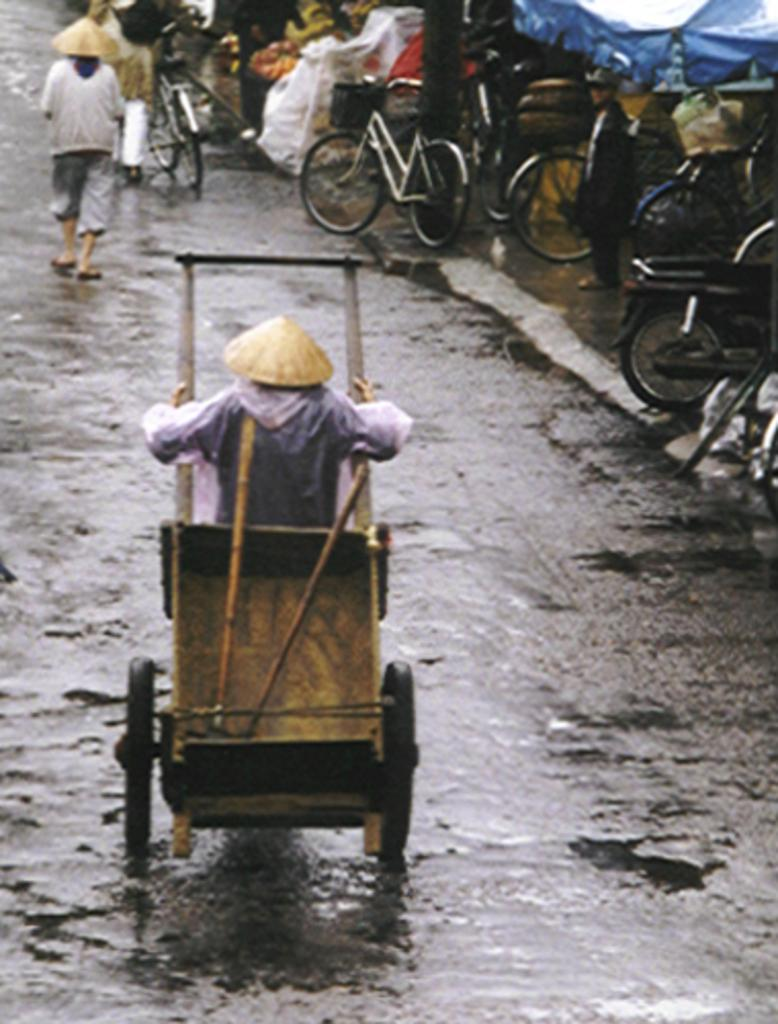What is the main subject of the image? There is a person in the center of the image holding a trolley. What is the person in the image doing? The person is walking. Can you describe the background of the image? There are other persons walking in the background of the image, as well as bicycles and other objects. What type of grain can be seen growing in the cave in the image? There is no cave or grain present in the image. 